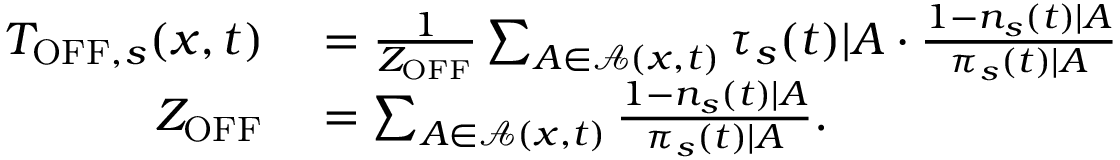<formula> <loc_0><loc_0><loc_500><loc_500>\begin{array} { r l } { T _ { O F F , s } ( x , t ) } & = \frac { 1 } { Z _ { O F F } } \sum _ { A \in \mathcal { A } ( x , t ) } \tau _ { s } ( t ) | A \cdot \frac { 1 - n _ { s } ( t ) | A } { \pi _ { s } ( t ) | A } } \\ { Z _ { O F F } } & = \sum _ { A \in \mathcal { A } ( x , t ) } \frac { 1 - n _ { s } ( t ) | A } { \pi _ { s } ( t ) | A } . } \end{array}</formula> 